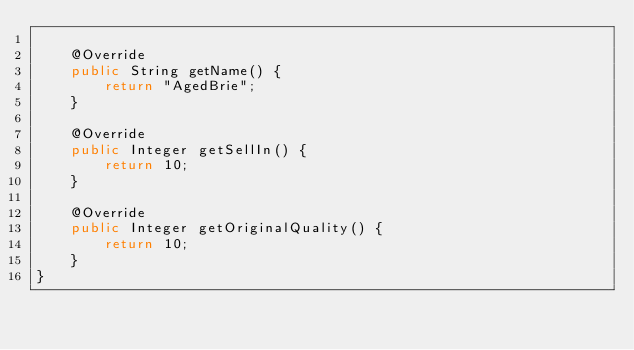<code> <loc_0><loc_0><loc_500><loc_500><_Java_>
    @Override
    public String getName() {
        return "AgedBrie";
    }

    @Override
    public Integer getSellIn() {
        return 10;
    }

    @Override
    public Integer getOriginalQuality() {
        return 10;
    }
}
</code> 